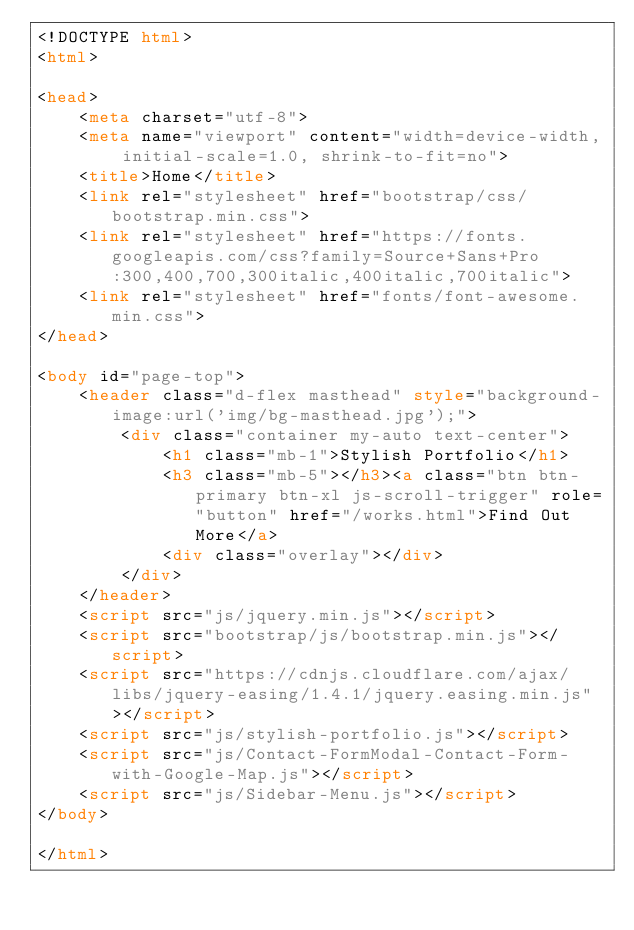<code> <loc_0><loc_0><loc_500><loc_500><_HTML_><!DOCTYPE html>
<html>

<head>
    <meta charset="utf-8">
    <meta name="viewport" content="width=device-width, initial-scale=1.0, shrink-to-fit=no">
    <title>Home</title>
    <link rel="stylesheet" href="bootstrap/css/bootstrap.min.css">
    <link rel="stylesheet" href="https://fonts.googleapis.com/css?family=Source+Sans+Pro:300,400,700,300italic,400italic,700italic">
    <link rel="stylesheet" href="fonts/font-awesome.min.css">
</head>

<body id="page-top">
    <header class="d-flex masthead" style="background-image:url('img/bg-masthead.jpg');">
        <div class="container my-auto text-center">
            <h1 class="mb-1">Stylish Portfolio</h1>
            <h3 class="mb-5"></h3><a class="btn btn-primary btn-xl js-scroll-trigger" role="button" href="/works.html">Find Out More</a>
            <div class="overlay"></div>
        </div>
    </header>
    <script src="js/jquery.min.js"></script>
    <script src="bootstrap/js/bootstrap.min.js"></script>
    <script src="https://cdnjs.cloudflare.com/ajax/libs/jquery-easing/1.4.1/jquery.easing.min.js"></script>
    <script src="js/stylish-portfolio.js"></script>
    <script src="js/Contact-FormModal-Contact-Form-with-Google-Map.js"></script>
    <script src="js/Sidebar-Menu.js"></script>
</body>

</html></code> 